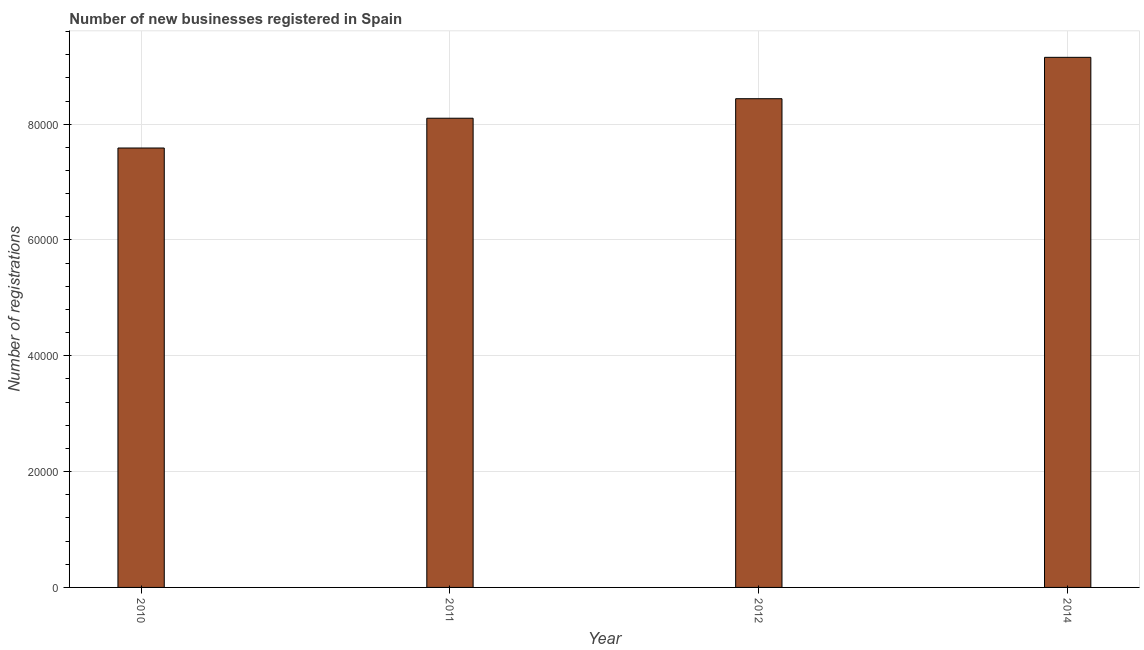What is the title of the graph?
Your response must be concise. Number of new businesses registered in Spain. What is the label or title of the Y-axis?
Your response must be concise. Number of registrations. What is the number of new business registrations in 2012?
Give a very brief answer. 8.44e+04. Across all years, what is the maximum number of new business registrations?
Keep it short and to the point. 9.15e+04. Across all years, what is the minimum number of new business registrations?
Offer a terse response. 7.59e+04. What is the sum of the number of new business registrations?
Your answer should be compact. 3.33e+05. What is the difference between the number of new business registrations in 2011 and 2012?
Give a very brief answer. -3372. What is the average number of new business registrations per year?
Your answer should be compact. 8.32e+04. What is the median number of new business registrations?
Provide a short and direct response. 8.27e+04. In how many years, is the number of new business registrations greater than 68000 ?
Provide a short and direct response. 4. Do a majority of the years between 2011 and 2012 (inclusive) have number of new business registrations greater than 72000 ?
Your answer should be compact. Yes. What is the ratio of the number of new business registrations in 2010 to that in 2011?
Your answer should be very brief. 0.94. Is the number of new business registrations in 2010 less than that in 2012?
Your answer should be very brief. Yes. Is the difference between the number of new business registrations in 2010 and 2012 greater than the difference between any two years?
Offer a terse response. No. What is the difference between the highest and the second highest number of new business registrations?
Give a very brief answer. 7145. Is the sum of the number of new business registrations in 2012 and 2014 greater than the maximum number of new business registrations across all years?
Give a very brief answer. Yes. What is the difference between the highest and the lowest number of new business registrations?
Offer a terse response. 1.57e+04. How many bars are there?
Ensure brevity in your answer.  4. What is the difference between two consecutive major ticks on the Y-axis?
Provide a short and direct response. 2.00e+04. Are the values on the major ticks of Y-axis written in scientific E-notation?
Offer a very short reply. No. What is the Number of registrations of 2010?
Keep it short and to the point. 7.59e+04. What is the Number of registrations of 2011?
Your answer should be compact. 8.10e+04. What is the Number of registrations in 2012?
Your response must be concise. 8.44e+04. What is the Number of registrations of 2014?
Offer a very short reply. 9.15e+04. What is the difference between the Number of registrations in 2010 and 2011?
Your response must be concise. -5142. What is the difference between the Number of registrations in 2010 and 2012?
Provide a succinct answer. -8514. What is the difference between the Number of registrations in 2010 and 2014?
Offer a very short reply. -1.57e+04. What is the difference between the Number of registrations in 2011 and 2012?
Provide a short and direct response. -3372. What is the difference between the Number of registrations in 2011 and 2014?
Give a very brief answer. -1.05e+04. What is the difference between the Number of registrations in 2012 and 2014?
Make the answer very short. -7145. What is the ratio of the Number of registrations in 2010 to that in 2011?
Keep it short and to the point. 0.94. What is the ratio of the Number of registrations in 2010 to that in 2012?
Ensure brevity in your answer.  0.9. What is the ratio of the Number of registrations in 2010 to that in 2014?
Keep it short and to the point. 0.83. What is the ratio of the Number of registrations in 2011 to that in 2012?
Your answer should be very brief. 0.96. What is the ratio of the Number of registrations in 2011 to that in 2014?
Your answer should be very brief. 0.89. What is the ratio of the Number of registrations in 2012 to that in 2014?
Offer a terse response. 0.92. 